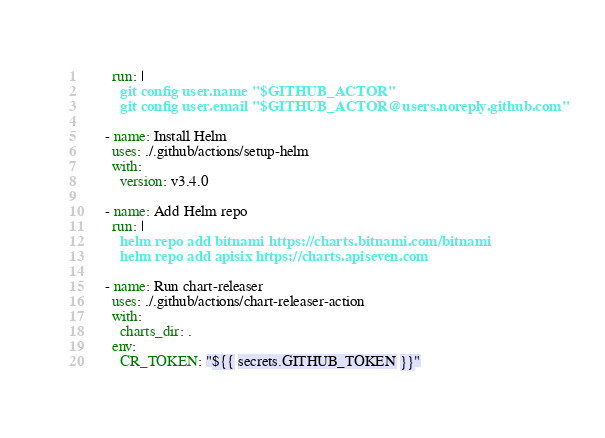<code> <loc_0><loc_0><loc_500><loc_500><_YAML_>        run: |
          git config user.name "$GITHUB_ACTOR"
          git config user.email "$GITHUB_ACTOR@users.noreply.github.com"

      - name: Install Helm
        uses: ./.github/actions/setup-helm
        with:
          version: v3.4.0

      - name: Add Helm repo
        run: |
          helm repo add bitnami https://charts.bitnami.com/bitnami
          helm repo add apisix https://charts.apiseven.com

      - name: Run chart-releaser
        uses: ./.github/actions/chart-releaser-action
        with:
          charts_dir: .
        env:
          CR_TOKEN: "${{ secrets.GITHUB_TOKEN }}"
</code> 